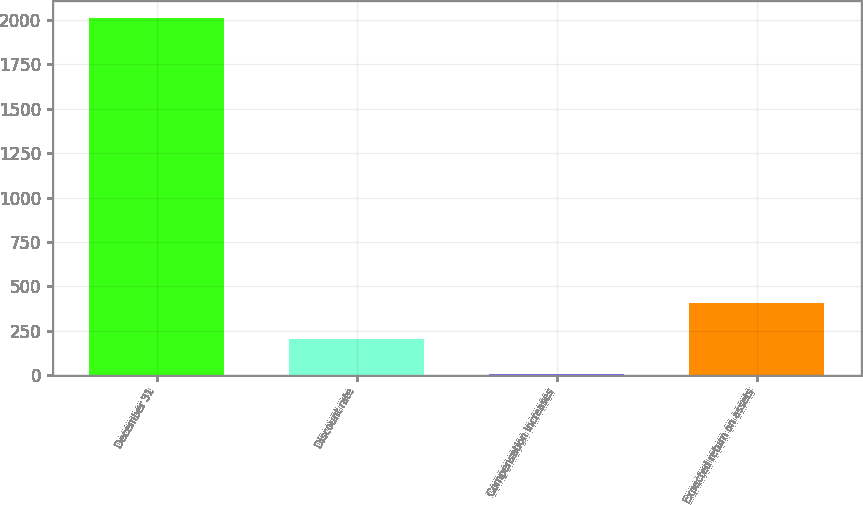Convert chart. <chart><loc_0><loc_0><loc_500><loc_500><bar_chart><fcel>December 31<fcel>Discount rate<fcel>Compensation increases<fcel>Expected return on assets<nl><fcel>2009<fcel>205<fcel>4.56<fcel>405.44<nl></chart> 